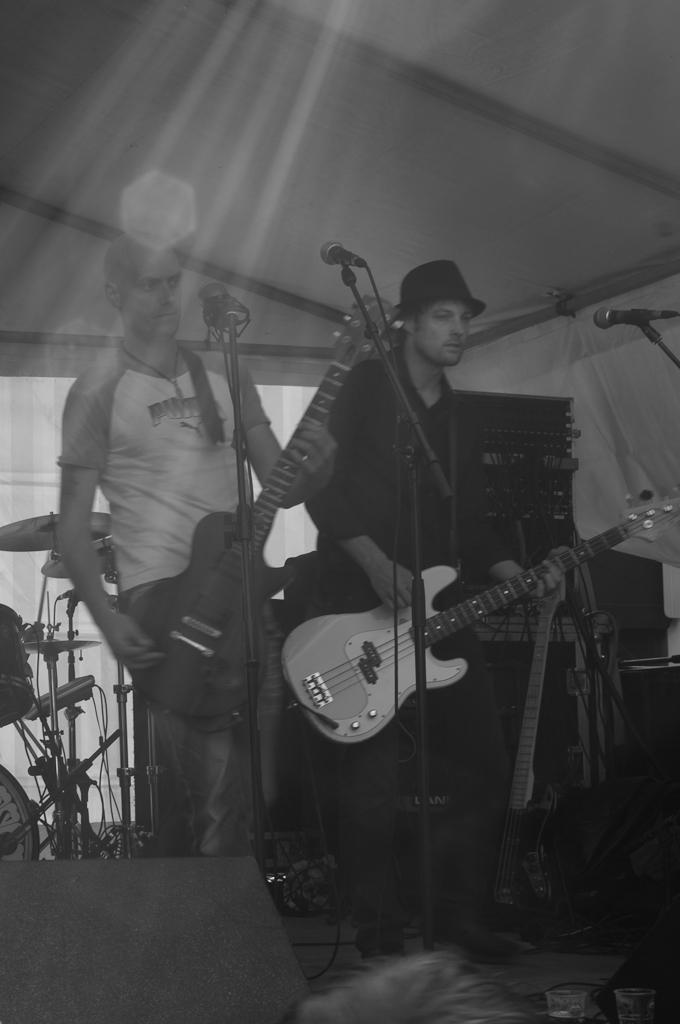How many people are in the image? There are people in the image, but the exact number is not specified. What are the people doing in the image? The people are standing in the image. What objects are the people holding in their hands? The people are holding guitars in their hands. What type of image can be seen in the picture? There is a black and white image in the picture. Where is the library located in the image? There is no library present in the image. What type of bottle can be seen on the table in the image? There is no table or bottle present in the image. 